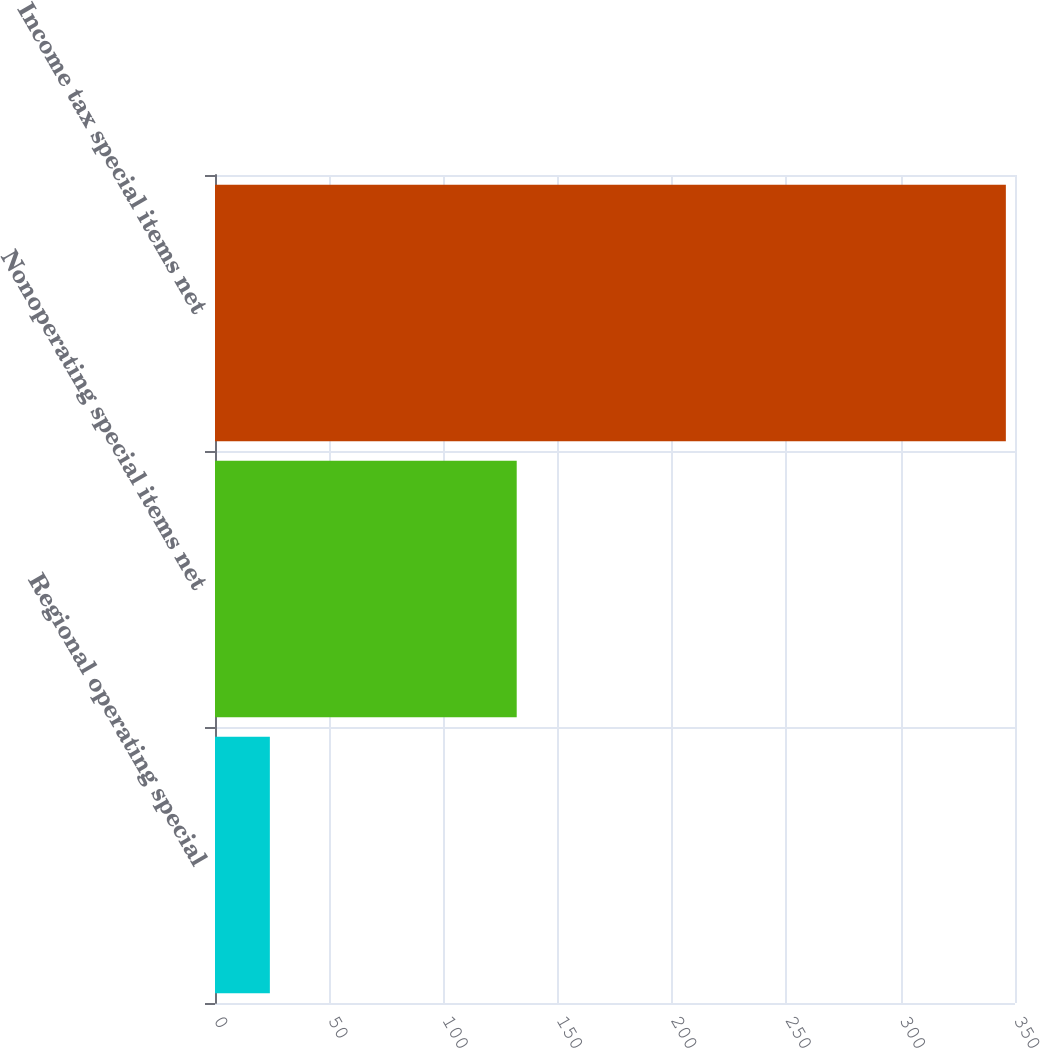<chart> <loc_0><loc_0><loc_500><loc_500><bar_chart><fcel>Regional operating special<fcel>Nonoperating special items net<fcel>Income tax special items net<nl><fcel>24<fcel>132<fcel>346<nl></chart> 